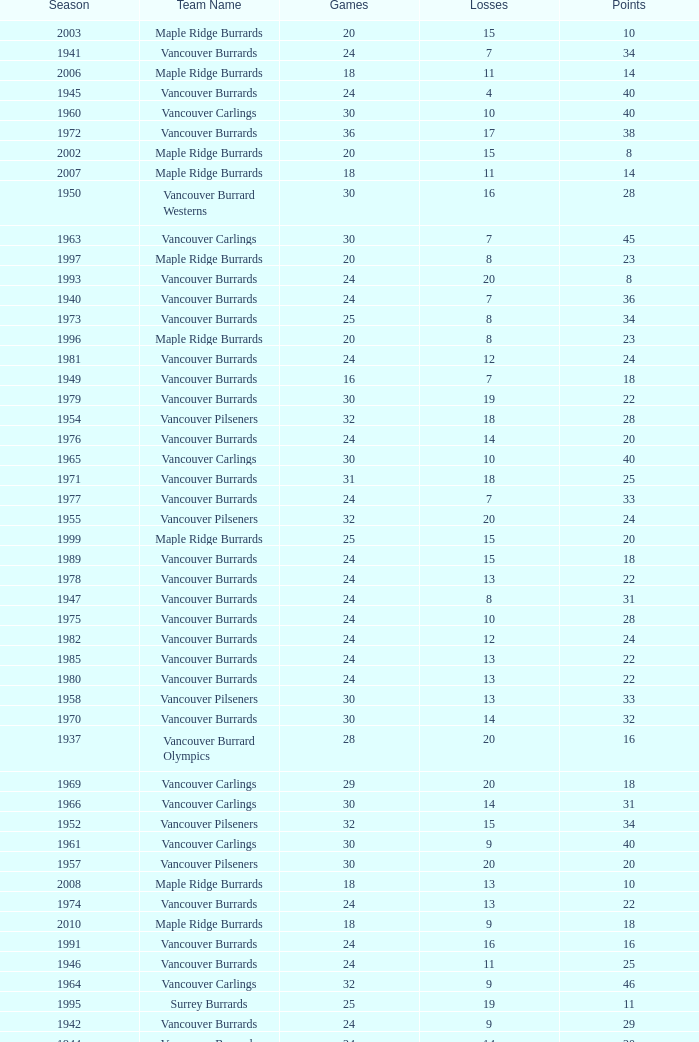What's the sum of points for the 1963 season when there are more than 30 games? None. 